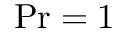<formula> <loc_0><loc_0><loc_500><loc_500>P r = 1</formula> 